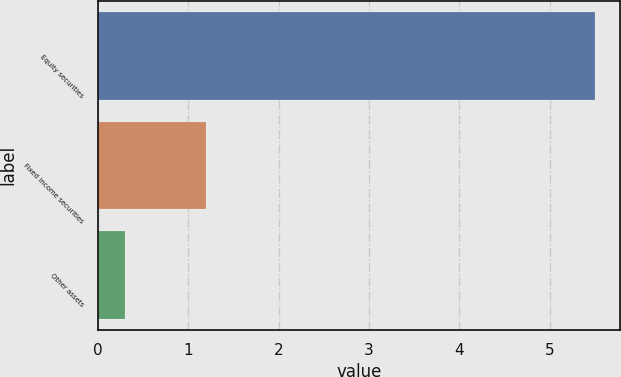Convert chart to OTSL. <chart><loc_0><loc_0><loc_500><loc_500><bar_chart><fcel>Equity securities<fcel>Fixed income securities<fcel>Other assets<nl><fcel>5.5<fcel>1.2<fcel>0.3<nl></chart> 